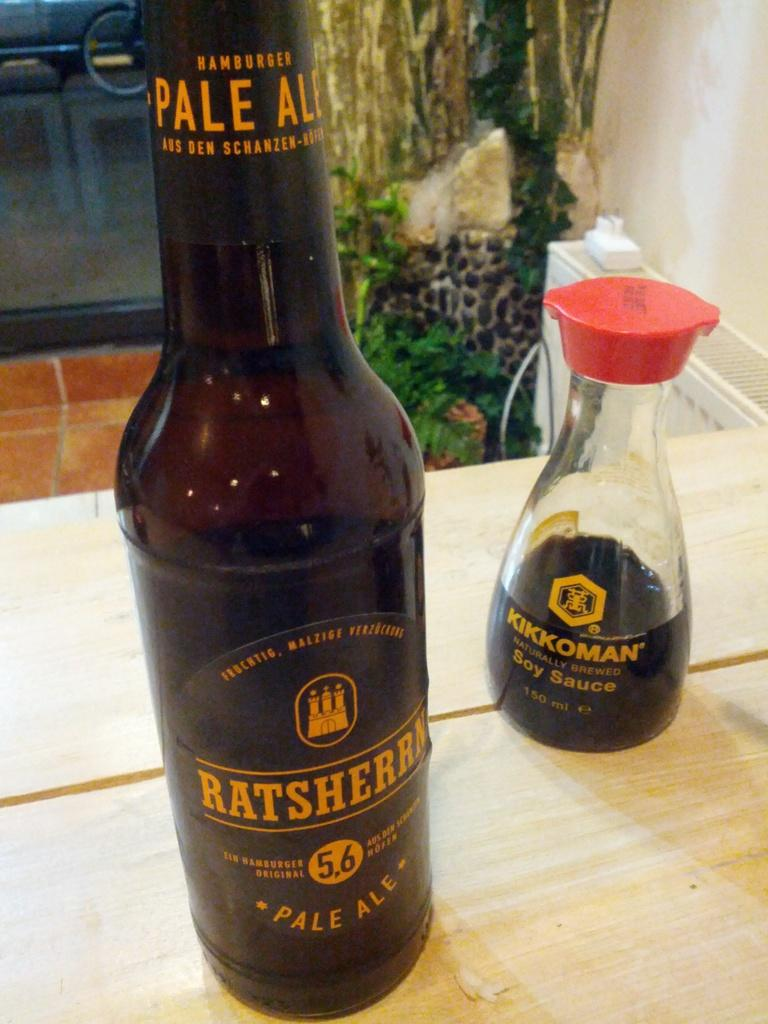<image>
Share a concise interpretation of the image provided. Dark Ratsherrn Pale Ale bottle next to a Kikkoman Soy Sauce. 